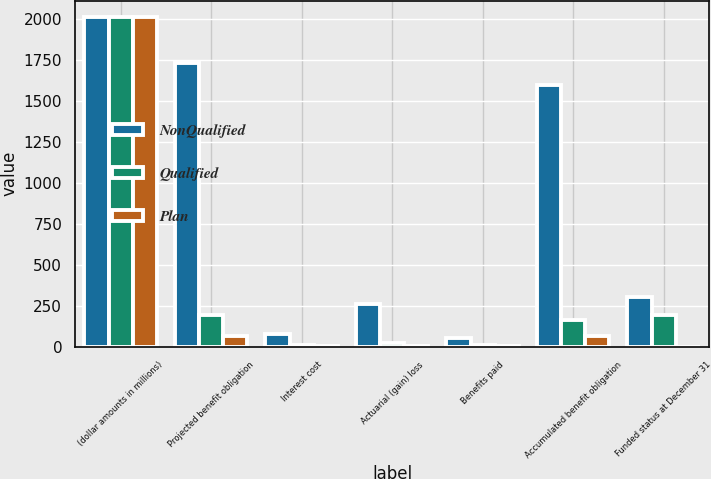Convert chart to OTSL. <chart><loc_0><loc_0><loc_500><loc_500><stacked_bar_chart><ecel><fcel>(dollar amounts in millions)<fcel>Projected benefit obligation<fcel>Interest cost<fcel>Actuarial (gain) loss<fcel>Benefits paid<fcel>Accumulated benefit obligation<fcel>Funded status at December 31<nl><fcel>NonQualified<fcel>2013<fcel>1731<fcel>80<fcel>260<fcel>56<fcel>1598<fcel>304<nl><fcel>Qualified<fcel>2013<fcel>195<fcel>9<fcel>21<fcel>9<fcel>163<fcel>195<nl><fcel>Plan<fcel>2013<fcel>69<fcel>3<fcel>7<fcel>6<fcel>69<fcel>2<nl></chart> 